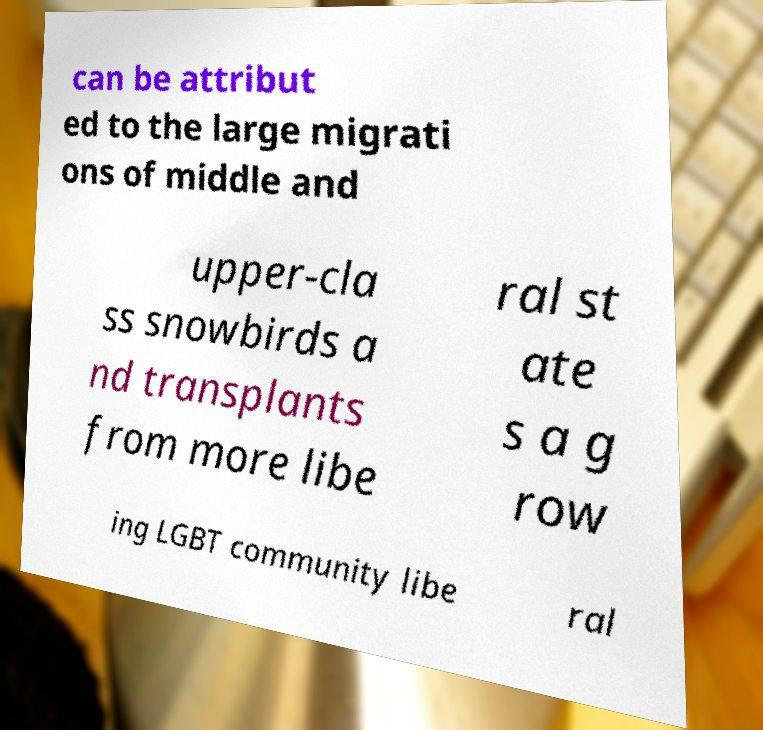Could you extract and type out the text from this image? can be attribut ed to the large migrati ons of middle and upper-cla ss snowbirds a nd transplants from more libe ral st ate s a g row ing LGBT community libe ral 